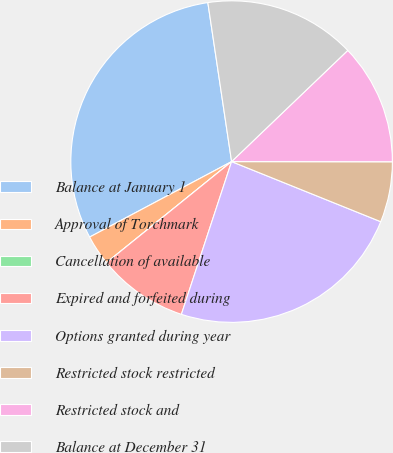<chart> <loc_0><loc_0><loc_500><loc_500><pie_chart><fcel>Balance at January 1<fcel>Approval of Torchmark<fcel>Cancellation of available<fcel>Expired and forfeited during<fcel>Options granted during year<fcel>Restricted stock restricted<fcel>Restricted stock and<fcel>Balance at December 31<nl><fcel>30.42%<fcel>3.04%<fcel>0.0%<fcel>9.13%<fcel>23.96%<fcel>6.08%<fcel>12.17%<fcel>15.21%<nl></chart> 